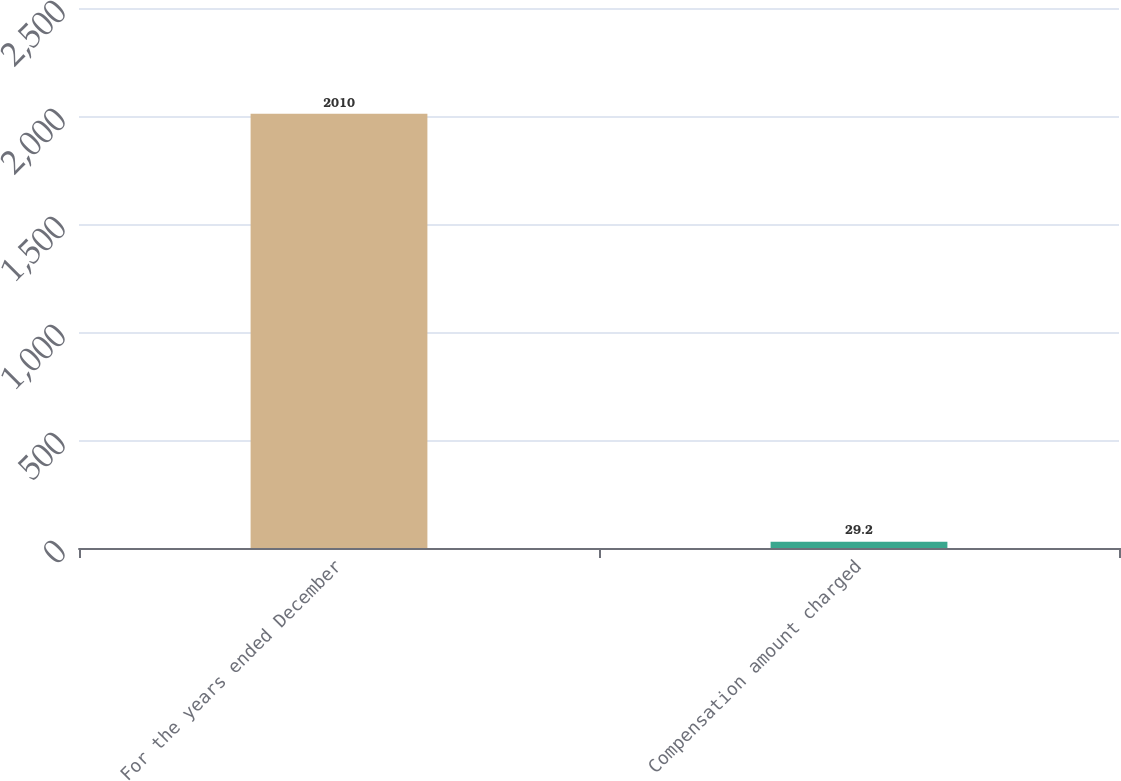<chart> <loc_0><loc_0><loc_500><loc_500><bar_chart><fcel>For the years ended December<fcel>Compensation amount charged<nl><fcel>2010<fcel>29.2<nl></chart> 